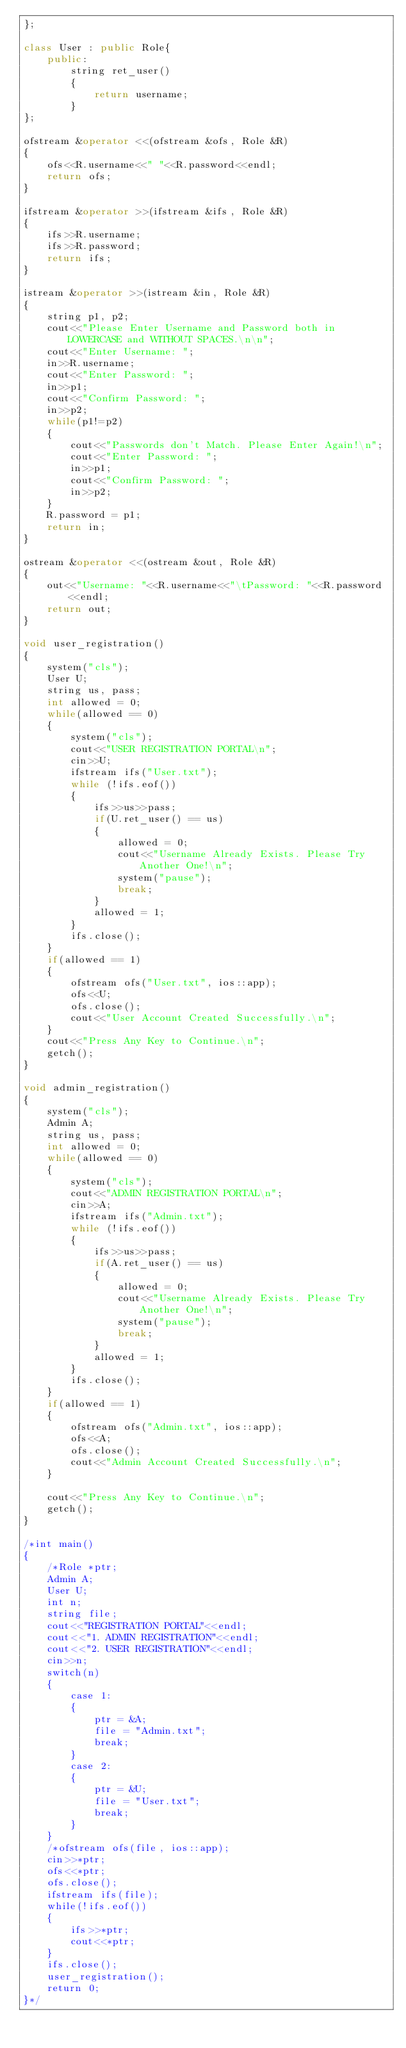<code> <loc_0><loc_0><loc_500><loc_500><_C++_>};

class User : public Role{
    public:
        string ret_user()
        {
            return username;
        }
};

ofstream &operator <<(ofstream &ofs, Role &R)
{
    ofs<<R.username<<" "<<R.password<<endl;
    return ofs;
}

ifstream &operator >>(ifstream &ifs, Role &R)
{
    ifs>>R.username;
    ifs>>R.password;
    return ifs;
}

istream &operator >>(istream &in, Role &R)
{
    string p1, p2;
    cout<<"Please Enter Username and Password both in LOWERCASE and WITHOUT SPACES.\n\n";
    cout<<"Enter Username: ";
    in>>R.username;
    cout<<"Enter Password: ";
    in>>p1;
    cout<<"Confirm Password: ";
    in>>p2;
    while(p1!=p2)
    {
        cout<<"Passwords don't Match. Please Enter Again!\n";
        cout<<"Enter Password: ";
        in>>p1;
        cout<<"Confirm Password: ";
        in>>p2;
    }
    R.password = p1;
    return in;
}

ostream &operator <<(ostream &out, Role &R)
{
    out<<"Username: "<<R.username<<"\tPassword: "<<R.password<<endl;
    return out;
}

void user_registration()
{
    system("cls");
    User U;
    string us, pass;
    int allowed = 0;
    while(allowed == 0)
    {
        system("cls");
        cout<<"USER REGISTRATION PORTAL\n";
        cin>>U;
        ifstream ifs("User.txt");
        while (!ifs.eof())
        {
            ifs>>us>>pass;
            if(U.ret_user() == us)
            {
                allowed = 0;
                cout<<"Username Already Exists. Please Try Another One!\n";
                system("pause");
                break;
            }
            allowed = 1;
        }
        ifs.close();
    }
    if(allowed == 1)
    {
        ofstream ofs("User.txt", ios::app);
        ofs<<U;
        ofs.close();
        cout<<"User Account Created Successfully.\n";
    }
    cout<<"Press Any Key to Continue.\n";
    getch();
}

void admin_registration()
{
    system("cls");
    Admin A;
    string us, pass;
    int allowed = 0;
    while(allowed == 0)
    {
        system("cls");
        cout<<"ADMIN REGISTRATION PORTAL\n";
        cin>>A;
        ifstream ifs("Admin.txt");
        while (!ifs.eof())
        {
            ifs>>us>>pass;
            if(A.ret_user() == us)
            {
                allowed = 0;
                cout<<"Username Already Exists. Please Try Another One!\n";
                system("pause");
                break;
            }
            allowed = 1;
        }
        ifs.close();
    }
    if(allowed == 1)
    {
        ofstream ofs("Admin.txt", ios::app);
        ofs<<A;
        ofs.close();
        cout<<"Admin Account Created Successfully.\n";
    }
    
    cout<<"Press Any Key to Continue.\n";
    getch();
}

/*int main()
{
    /*Role *ptr;
    Admin A;
    User U;
    int n;
    string file;
    cout<<"REGISTRATION PORTAL"<<endl;
    cout<<"1. ADMIN REGISTRATION"<<endl;
    cout<<"2. USER REGISTRATION"<<endl;
    cin>>n;
    switch(n)
    {
        case 1:
        {
            ptr = &A;
            file = "Admin.txt";
            break;
        }
        case 2:
        {
            ptr = &U;
            file = "User.txt";
            break;
        }
    }
    /*ofstream ofs(file, ios::app);
    cin>>*ptr;
    ofs<<*ptr;
    ofs.close();
    ifstream ifs(file);
    while(!ifs.eof())
    {
        ifs>>*ptr;
        cout<<*ptr;
    }
    ifs.close();
    user_registration();
    return 0;
}*/</code> 